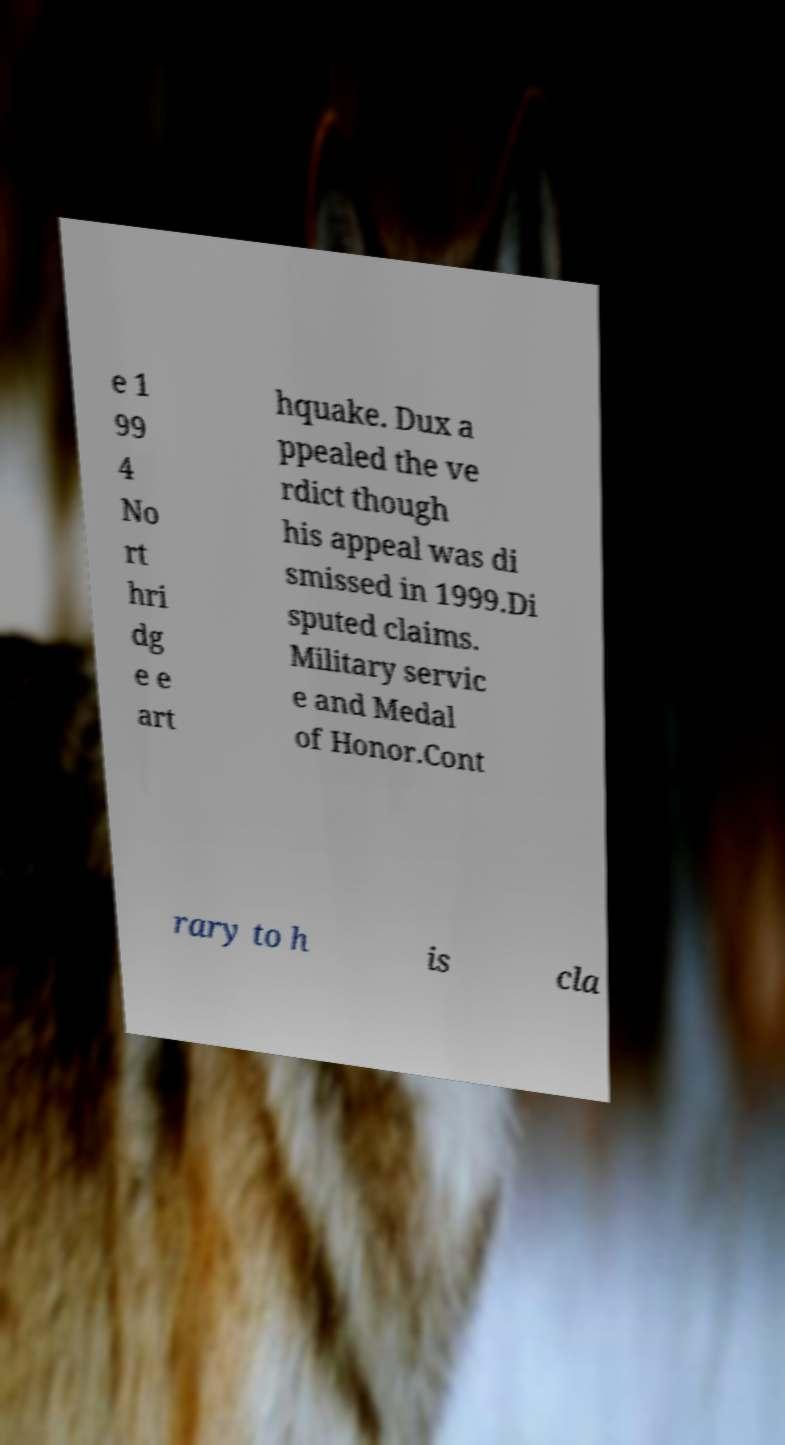What messages or text are displayed in this image? I need them in a readable, typed format. e 1 99 4 No rt hri dg e e art hquake. Dux a ppealed the ve rdict though his appeal was di smissed in 1999.Di sputed claims. Military servic e and Medal of Honor.Cont rary to h is cla 